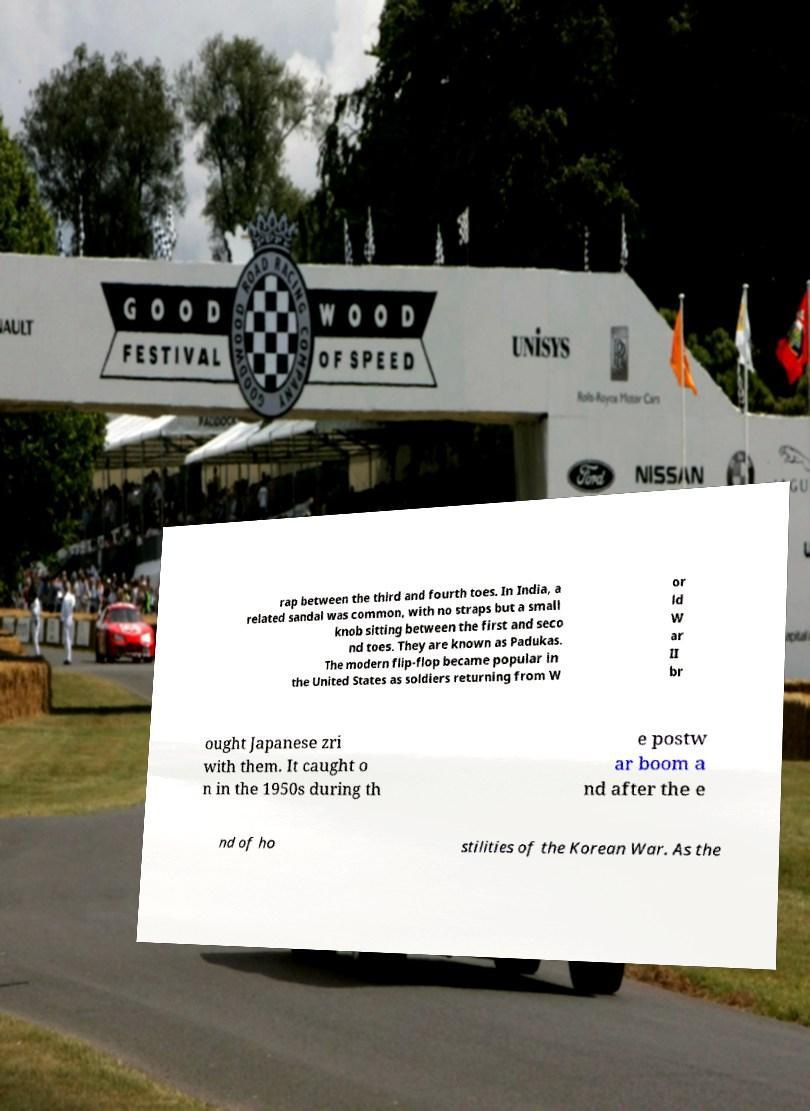There's text embedded in this image that I need extracted. Can you transcribe it verbatim? rap between the third and fourth toes. In India, a related sandal was common, with no straps but a small knob sitting between the first and seco nd toes. They are known as Padukas. The modern flip-flop became popular in the United States as soldiers returning from W or ld W ar II br ought Japanese zri with them. It caught o n in the 1950s during th e postw ar boom a nd after the e nd of ho stilities of the Korean War. As the 